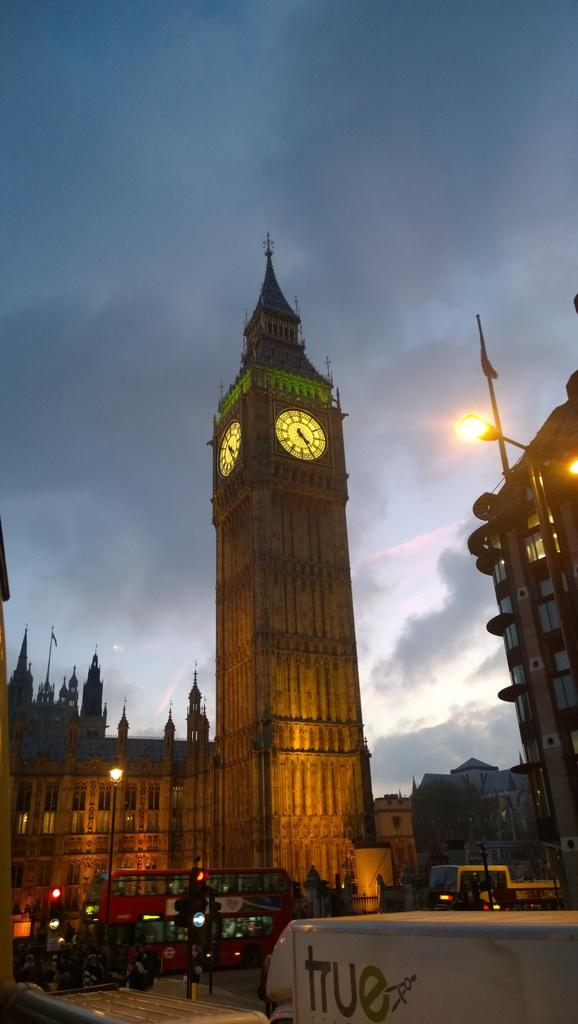What can be seen on the road in the image? There are vehicles on the road in the image. What type of structures are present in the image? There are buildings in the image. What specific feature can be identified among the buildings? There is a clock tower in the image. What are the poles in the image used for? The poles in the image are likely used for supporting lights or other infrastructure. What can be seen in the sky in the background of the image? The sky is visible in the background of the image. Where is the girl sitting in the image? There is no girl present in the image. What is the hook used for in the image? There is no hook present in the image. 